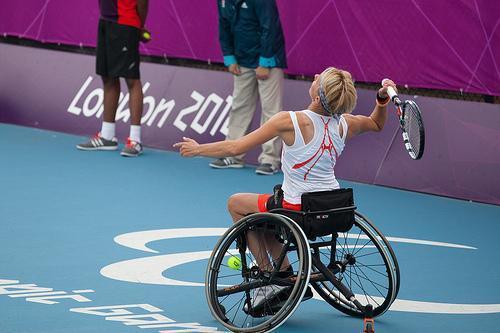How many people are shown?
Give a very brief answer. 3. How many people are in wheel chairs?
Give a very brief answer. 1. 